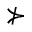Convert formula to latex. <formula><loc_0><loc_0><loc_500><loc_500>\nsucc</formula> 